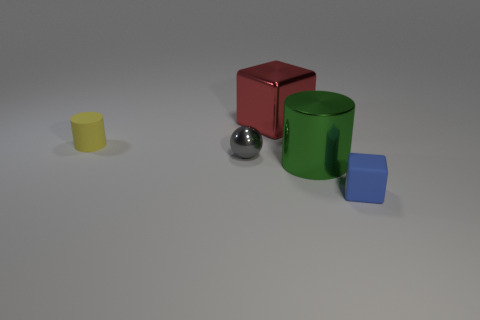Add 2 tiny blue rubber cubes. How many objects exist? 7 Subtract all cylinders. How many objects are left? 3 Add 5 green cylinders. How many green cylinders exist? 6 Subtract 0 cyan blocks. How many objects are left? 5 Subtract all balls. Subtract all tiny metallic objects. How many objects are left? 3 Add 5 yellow matte cylinders. How many yellow matte cylinders are left? 6 